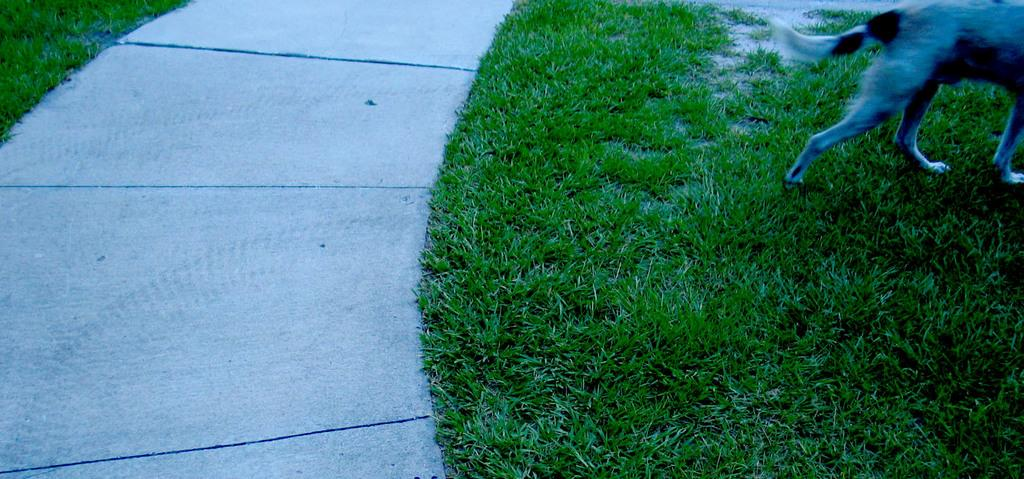What type of animal is present in the image? There is a dog in the image. Where is the dog located in the image? The dog is at the right top of the image. What type of natural environment is visible at the bottom of the image? There is grass visible at the bottom of the image. Can you see a hill in the background of the image? There is no hill visible in the image; it only features a dog and grass. Is there a maid walking on the road in the image? There is no road or maid present in the image. 